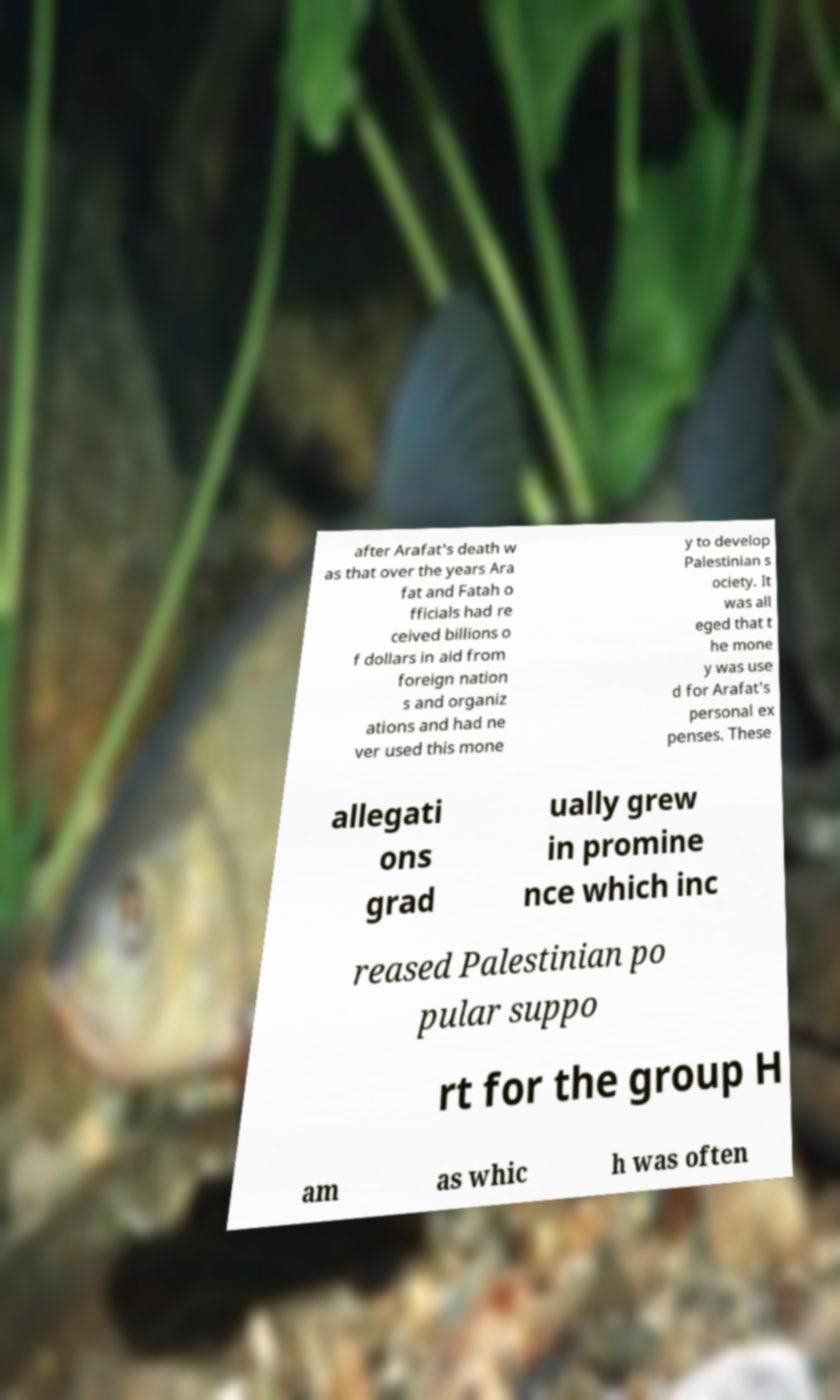Could you assist in decoding the text presented in this image and type it out clearly? after Arafat's death w as that over the years Ara fat and Fatah o fficials had re ceived billions o f dollars in aid from foreign nation s and organiz ations and had ne ver used this mone y to develop Palestinian s ociety. It was all eged that t he mone y was use d for Arafat's personal ex penses. These allegati ons grad ually grew in promine nce which inc reased Palestinian po pular suppo rt for the group H am as whic h was often 